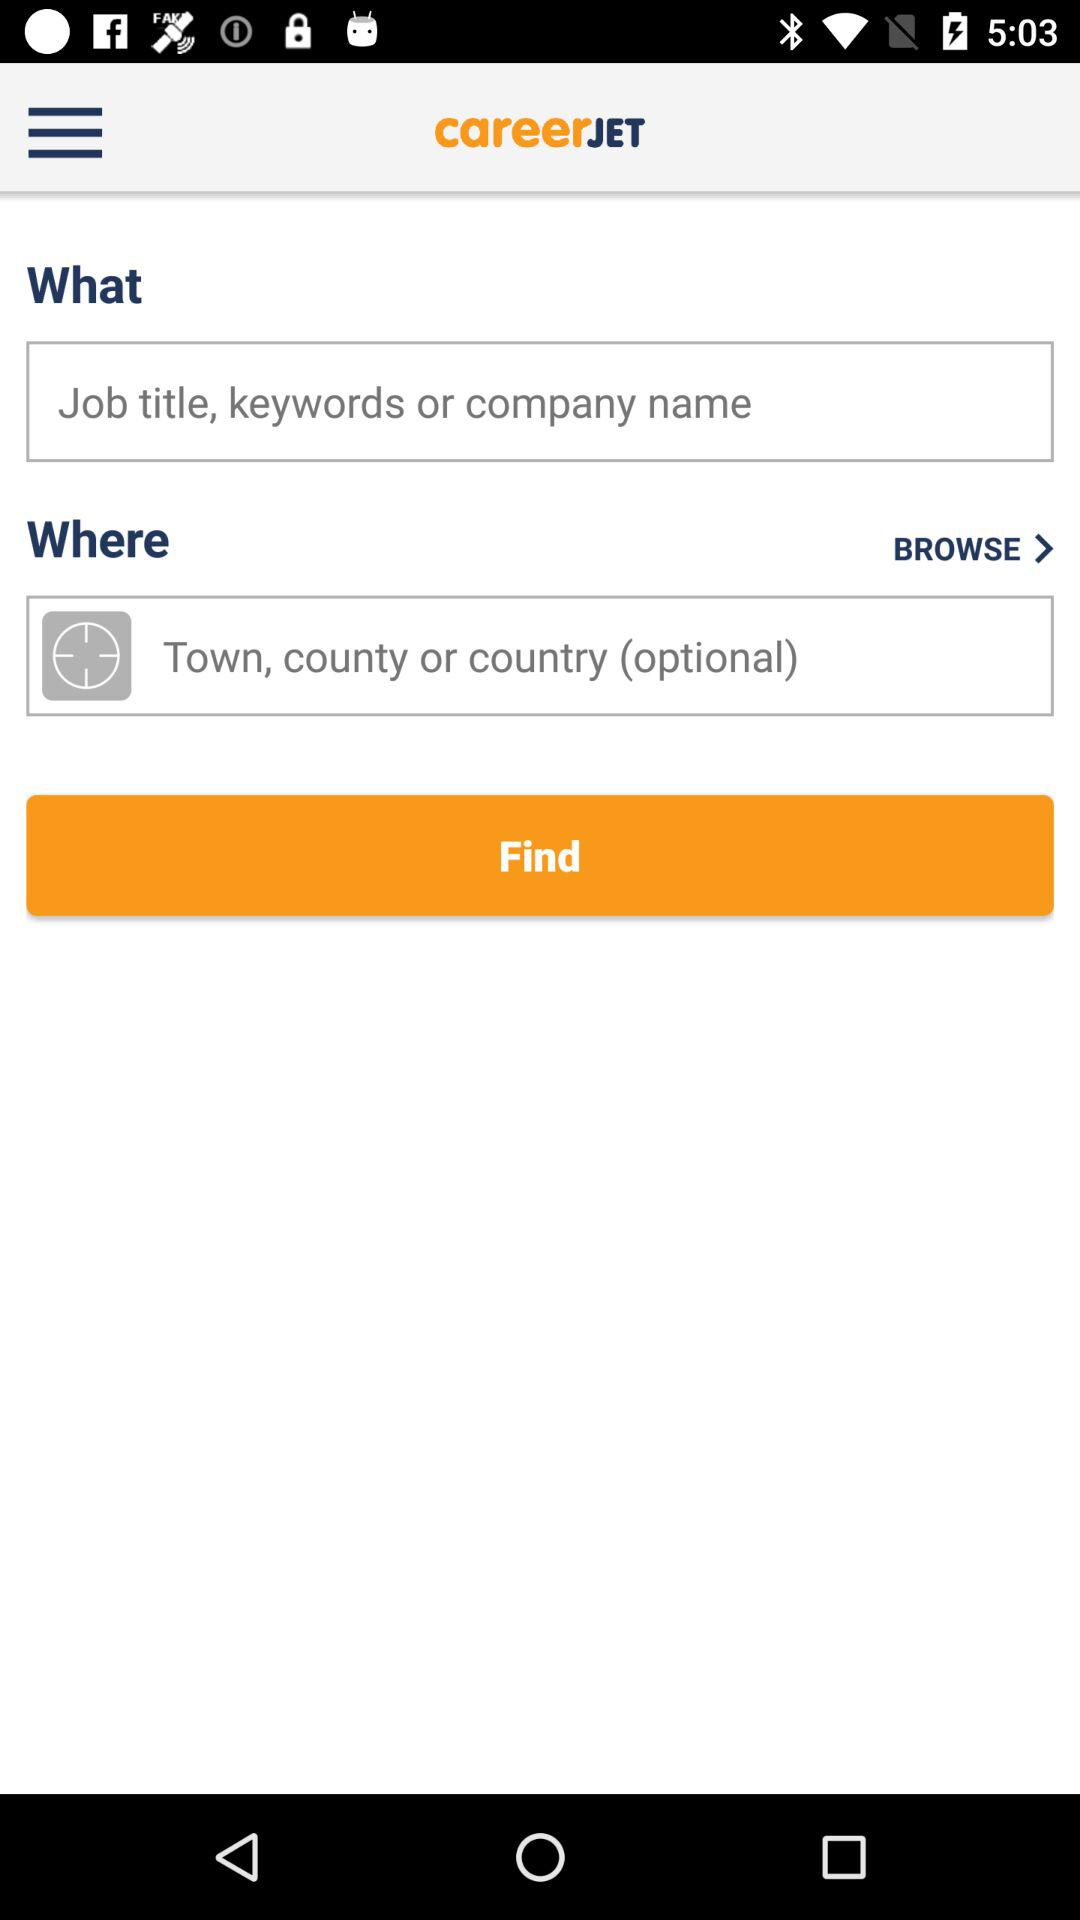What is the name of the application? The name of the application is "careerJET". 